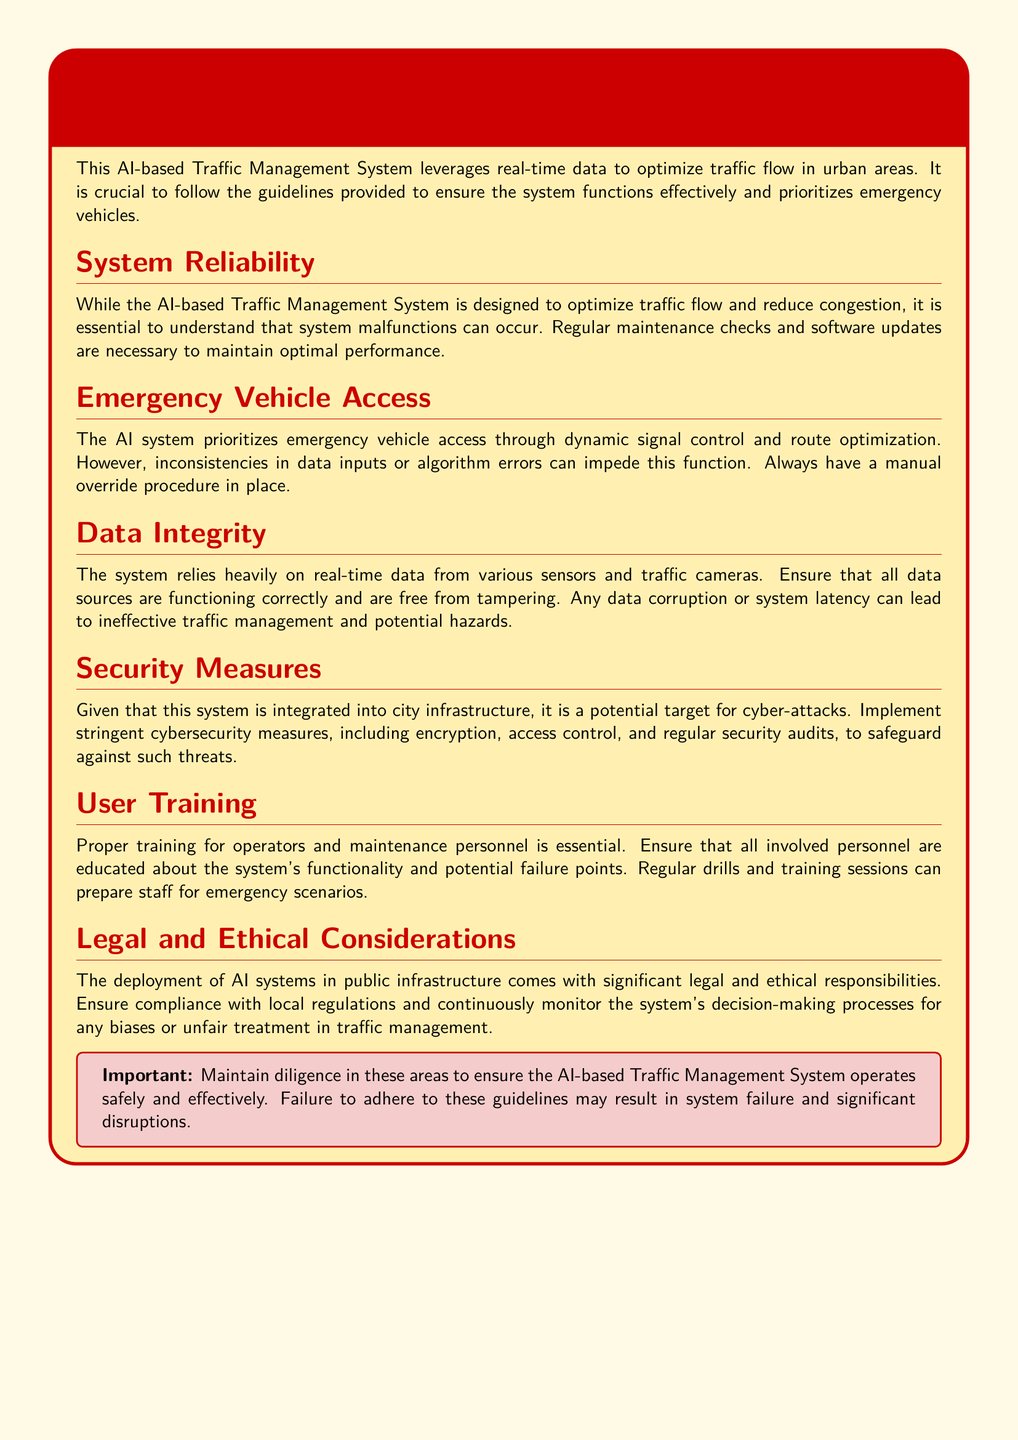What is the primary purpose of the AI-based Traffic Management System? The primary purpose is to optimize traffic flow in urban areas using real-time data.
Answer: Optimize traffic flow What should be ensured to avoid system failures? Emergency vehicle access should be prioritized to avoid system failures.
Answer: Emergency vehicle access What is necessary to maintain optimal performance of the system? Regular maintenance checks and software updates are necessary to maintain optimal performance.
Answer: Regular maintenance checks and software updates What is a critical risk for the AI-based Traffic Management System? The system is a potential target for cyber-attacks.
Answer: Cyber-attacks Which procedure should always be in place for emergency access? Always have a manual override procedure in place.
Answer: Manual override procedure What can data corruption lead to in traffic management? Data corruption can lead to ineffective traffic management and potential hazards.
Answer: Ineffective traffic management What is essential for operators and maintenance personnel? Proper training for operators and maintenance personnel is essential.
Answer: Proper training What should be implemented to safeguard against threats? Stringent cybersecurity measures should be implemented to safeguard against threats.
Answer: Stringent cybersecurity measures What should be continuously monitored for biases in traffic management? The system's decision-making processes should be continuously monitored for biases.
Answer: Decision-making processes 